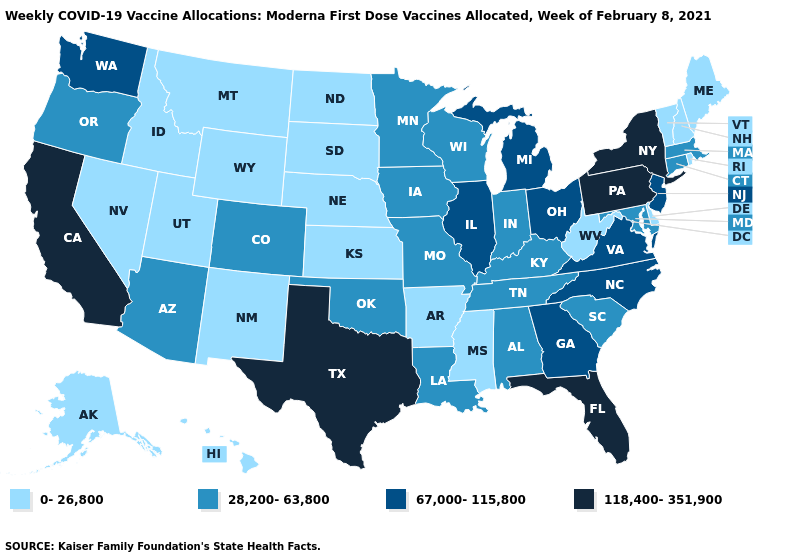Name the states that have a value in the range 67,000-115,800?
Concise answer only. Georgia, Illinois, Michigan, New Jersey, North Carolina, Ohio, Virginia, Washington. Does Illinois have the highest value in the USA?
Keep it brief. No. What is the value of Colorado?
Quick response, please. 28,200-63,800. Which states have the highest value in the USA?
Give a very brief answer. California, Florida, New York, Pennsylvania, Texas. What is the value of California?
Write a very short answer. 118,400-351,900. What is the highest value in states that border Colorado?
Short answer required. 28,200-63,800. Does Nebraska have the lowest value in the USA?
Quick response, please. Yes. What is the value of Connecticut?
Give a very brief answer. 28,200-63,800. Does California have the highest value in the USA?
Give a very brief answer. Yes. Which states hav the highest value in the MidWest?
Quick response, please. Illinois, Michigan, Ohio. Among the states that border Maryland , which have the lowest value?
Write a very short answer. Delaware, West Virginia. Does the first symbol in the legend represent the smallest category?
Quick response, please. Yes. What is the lowest value in states that border Kansas?
Keep it brief. 0-26,800. What is the value of Delaware?
Quick response, please. 0-26,800. What is the value of Oklahoma?
Short answer required. 28,200-63,800. 